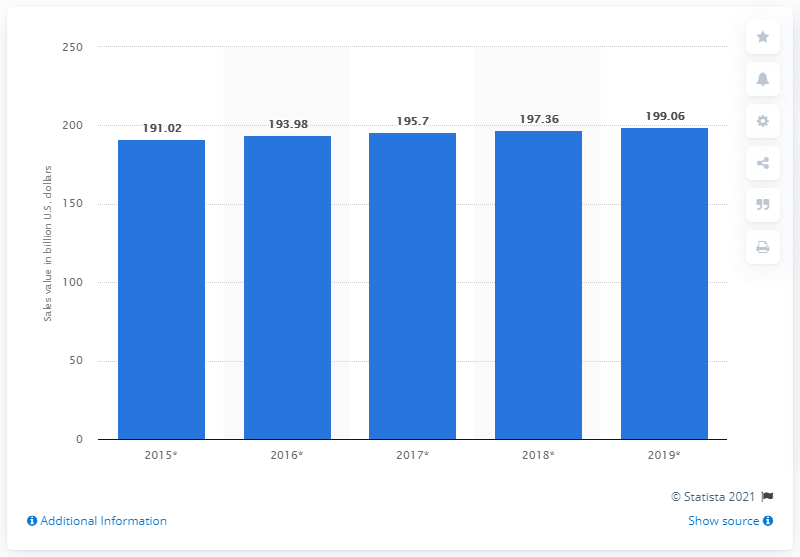Point out several critical features in this image. It is estimated that the sales value of packaged food in Japan in U.S. dollars in 2015 was 191.02. 